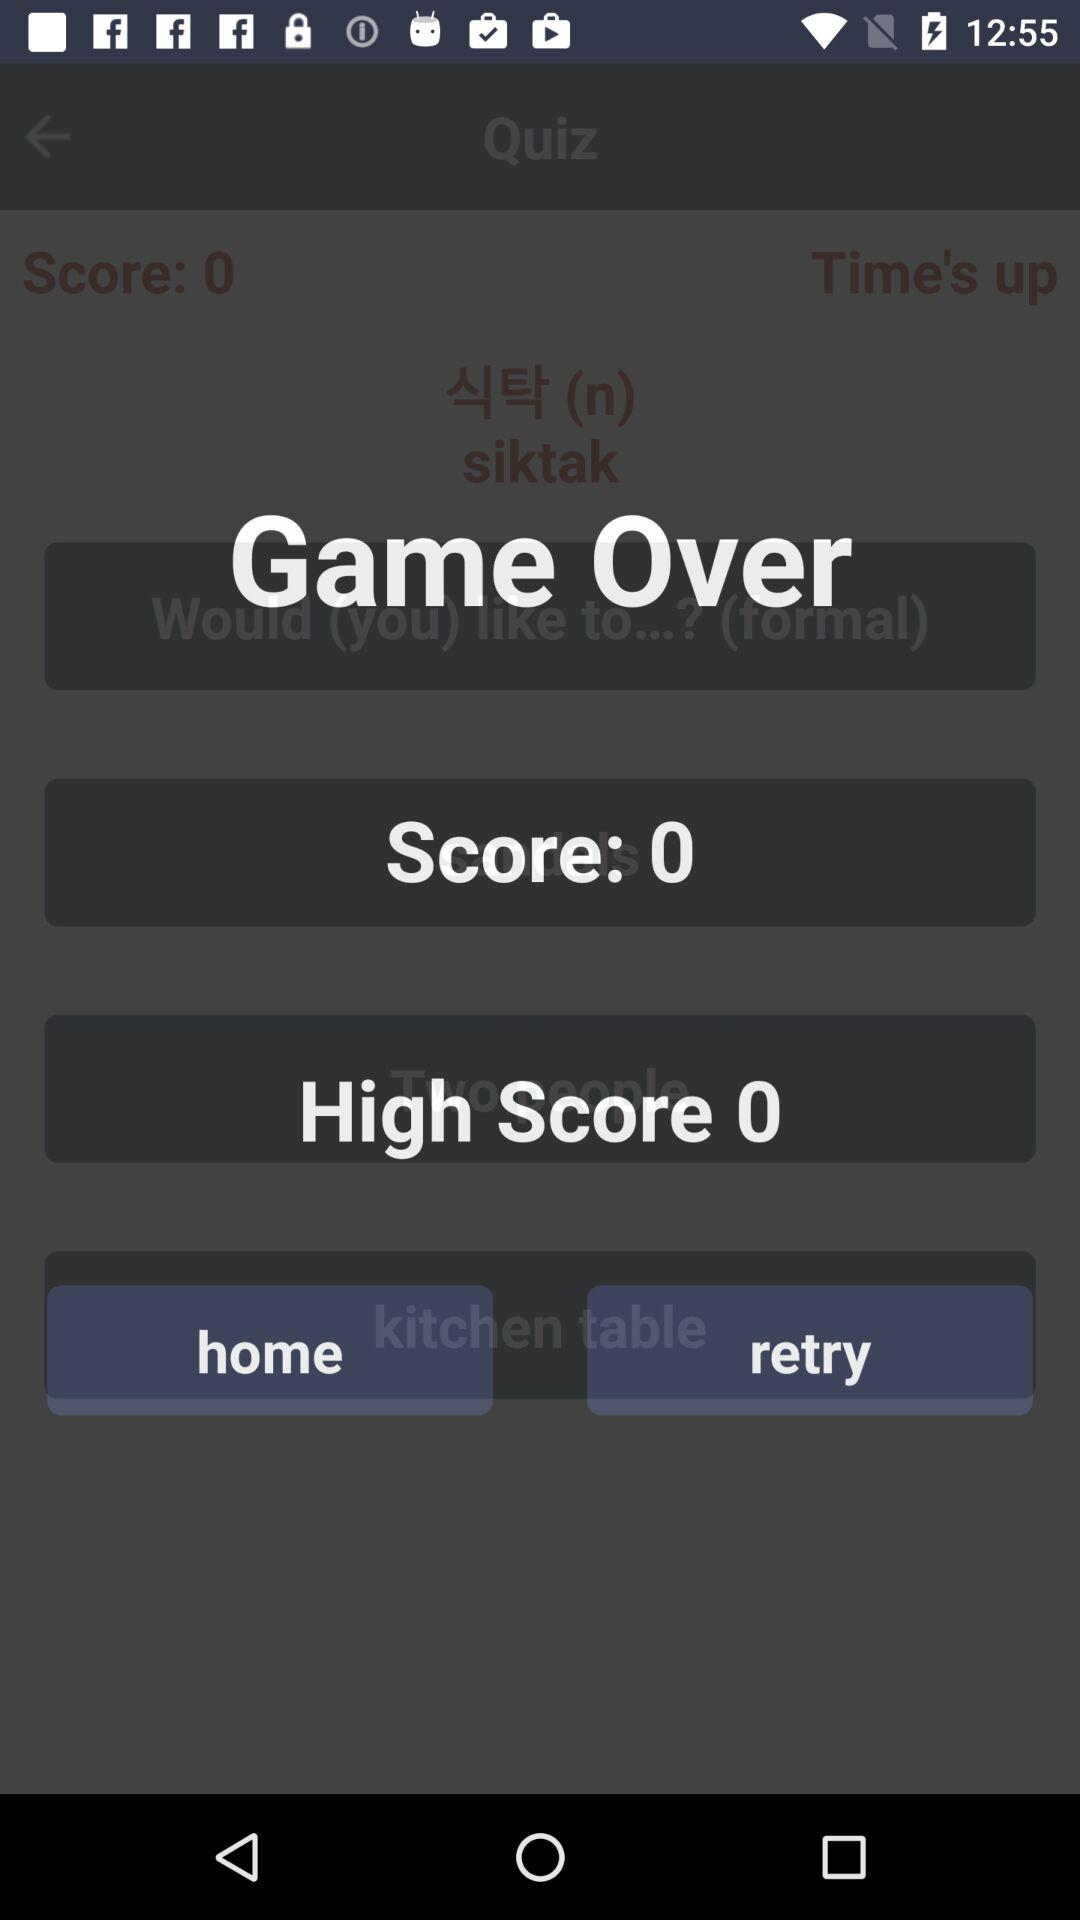What is the score? The score is 0. 